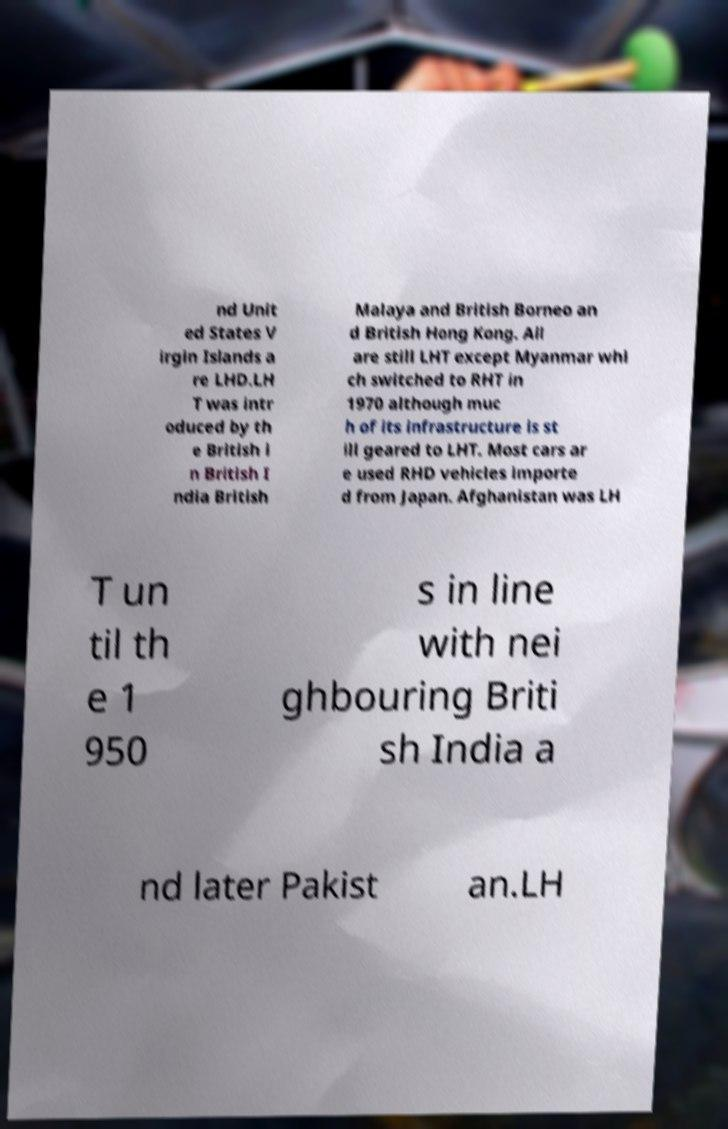Can you accurately transcribe the text from the provided image for me? nd Unit ed States V irgin Islands a re LHD.LH T was intr oduced by th e British i n British I ndia British Malaya and British Borneo an d British Hong Kong. All are still LHT except Myanmar whi ch switched to RHT in 1970 although muc h of its infrastructure is st ill geared to LHT. Most cars ar e used RHD vehicles importe d from Japan. Afghanistan was LH T un til th e 1 950 s in line with nei ghbouring Briti sh India a nd later Pakist an.LH 